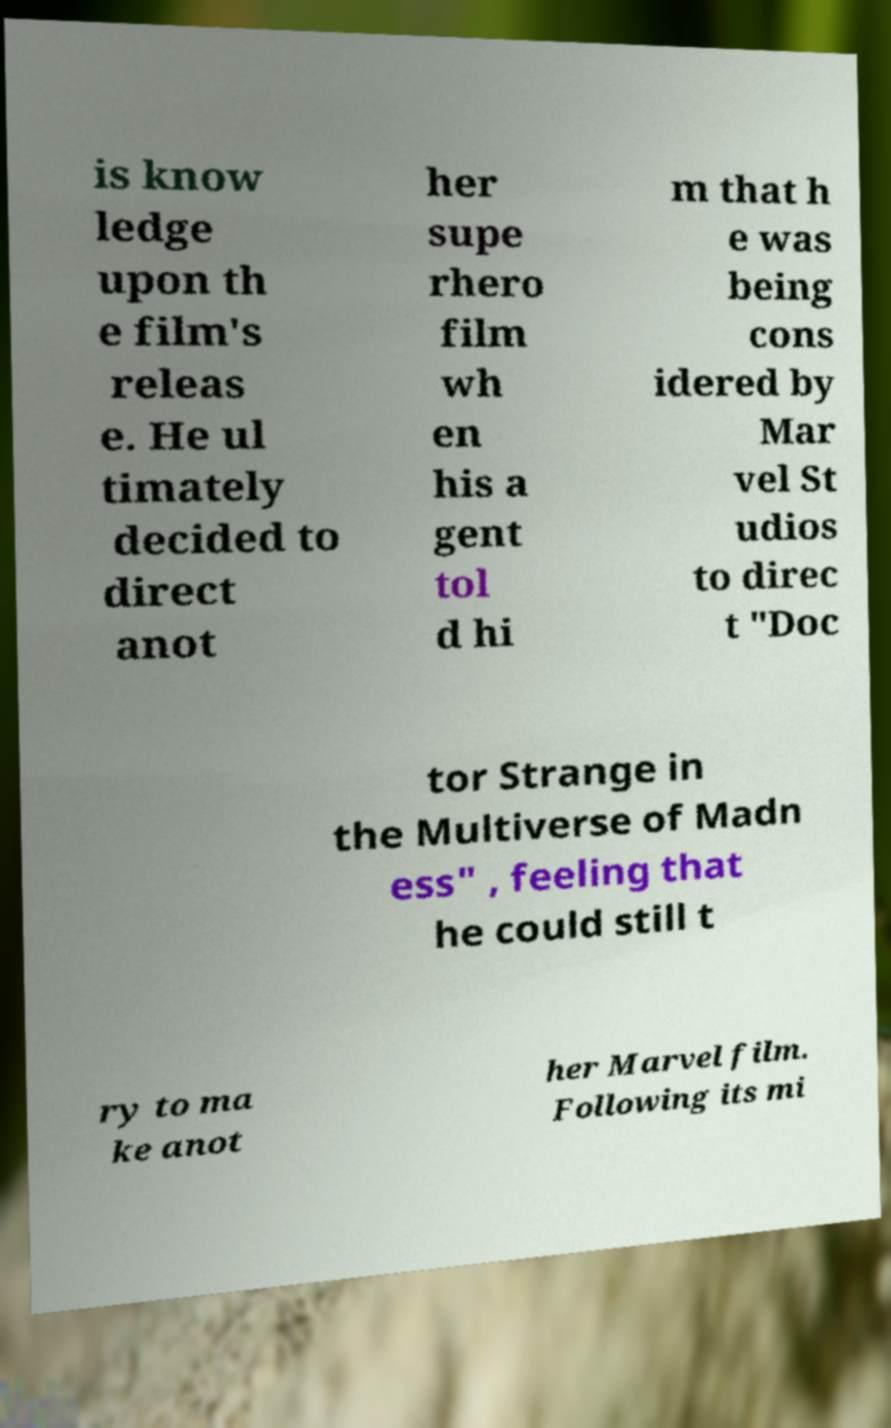There's text embedded in this image that I need extracted. Can you transcribe it verbatim? is know ledge upon th e film's releas e. He ul timately decided to direct anot her supe rhero film wh en his a gent tol d hi m that h e was being cons idered by Mar vel St udios to direc t "Doc tor Strange in the Multiverse of Madn ess" , feeling that he could still t ry to ma ke anot her Marvel film. Following its mi 